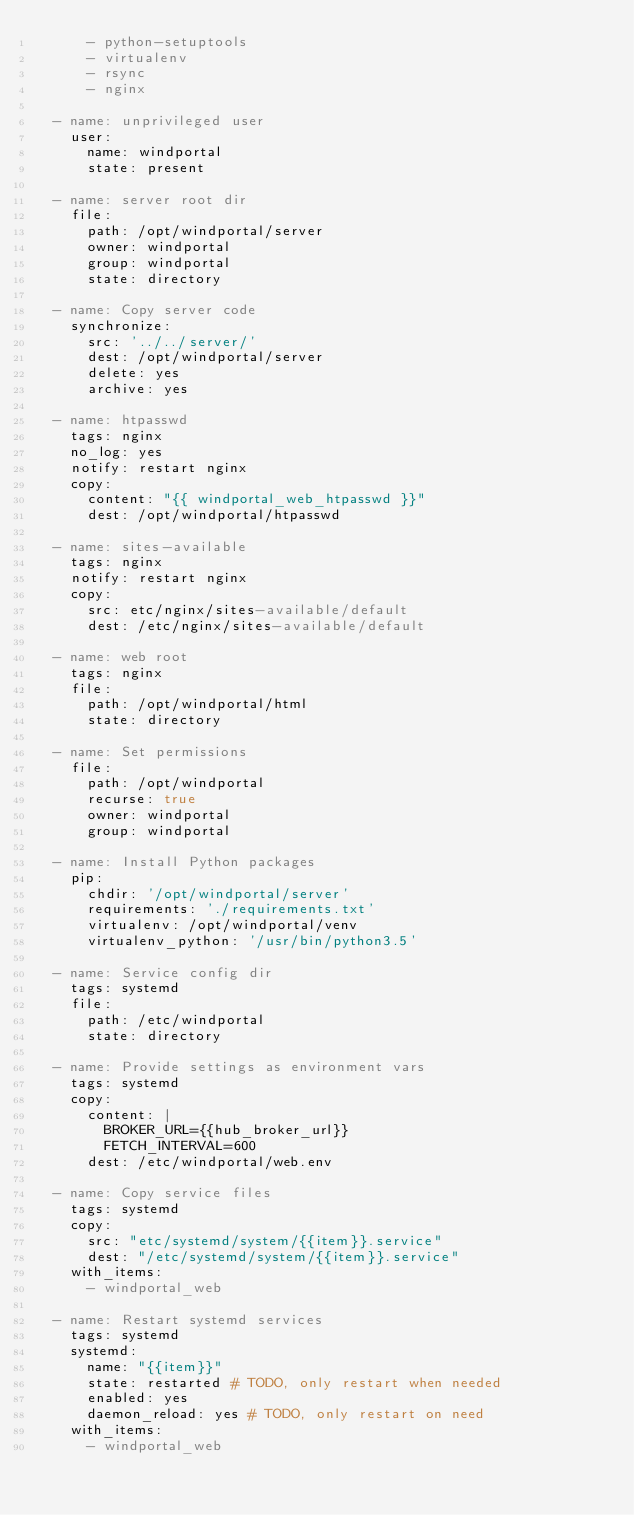Convert code to text. <code><loc_0><loc_0><loc_500><loc_500><_YAML_>      - python-setuptools
      - virtualenv
      - rsync
      - nginx

  - name: unprivileged user
    user:
      name: windportal
      state: present

  - name: server root dir
    file:
      path: /opt/windportal/server
      owner: windportal
      group: windportal
      state: directory

  - name: Copy server code
    synchronize:
      src: '../../server/'
      dest: /opt/windportal/server
      delete: yes
      archive: yes

  - name: htpasswd
    tags: nginx
    no_log: yes
    notify: restart nginx
    copy:
      content: "{{ windportal_web_htpasswd }}"
      dest: /opt/windportal/htpasswd

  - name: sites-available
    tags: nginx
    notify: restart nginx
    copy:
      src: etc/nginx/sites-available/default
      dest: /etc/nginx/sites-available/default

  - name: web root
    tags: nginx
    file:
      path: /opt/windportal/html
      state: directory

  - name: Set permissions
    file:
      path: /opt/windportal
      recurse: true
      owner: windportal
      group: windportal

  - name: Install Python packages
    pip:
      chdir: '/opt/windportal/server'
      requirements: './requirements.txt'
      virtualenv: /opt/windportal/venv
      virtualenv_python: '/usr/bin/python3.5'

  - name: Service config dir
    tags: systemd
    file:
      path: /etc/windportal
      state: directory

  - name: Provide settings as environment vars
    tags: systemd
    copy:
      content: |
        BROKER_URL={{hub_broker_url}}
        FETCH_INTERVAL=600
      dest: /etc/windportal/web.env

  - name: Copy service files
    tags: systemd
    copy:
      src: "etc/systemd/system/{{item}}.service"
      dest: "/etc/systemd/system/{{item}}.service"
    with_items:
      - windportal_web

  - name: Restart systemd services
    tags: systemd
    systemd:
      name: "{{item}}"
      state: restarted # TODO, only restart when needed 
      enabled: yes
      daemon_reload: yes # TODO, only restart on need
    with_items:
      - windportal_web
</code> 